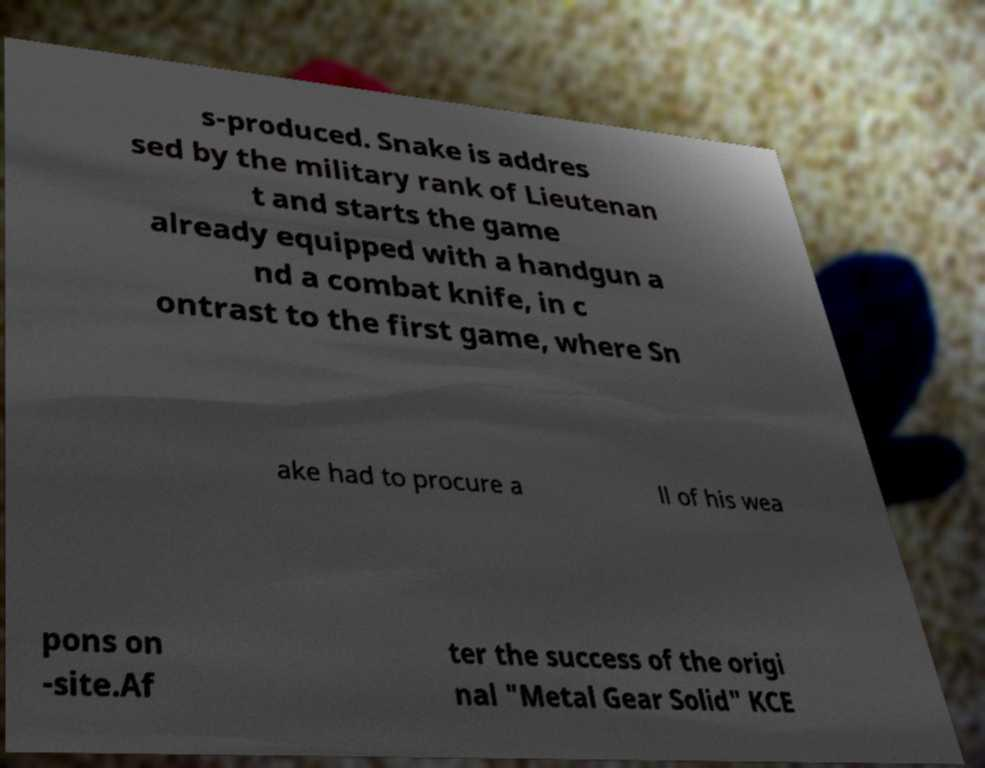Could you extract and type out the text from this image? s-produced. Snake is addres sed by the military rank of Lieutenan t and starts the game already equipped with a handgun a nd a combat knife, in c ontrast to the first game, where Sn ake had to procure a ll of his wea pons on -site.Af ter the success of the origi nal "Metal Gear Solid" KCE 